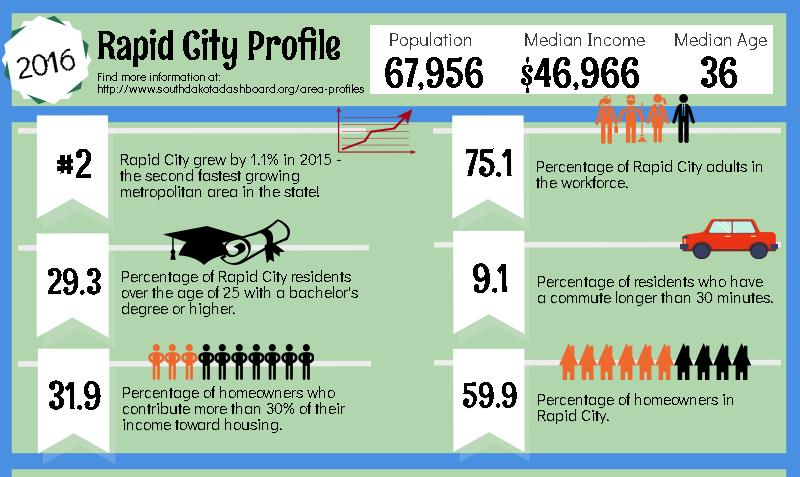Point out several critical features in this image. In Rapid City, a significant number of localities carry graduation or post-graduation. Specifically, 70.7% of localities have reported carrying graduation or post-graduation. According to a recent survey, approximately 40.1% of the population in Rapid City own their own homes. Approximately 90.9% of the people in Rapid City have a commute time of more than half an hour between their home and workplace. The inverse percentage of Rapid City grown-ups in the workforce is 24.9%. 